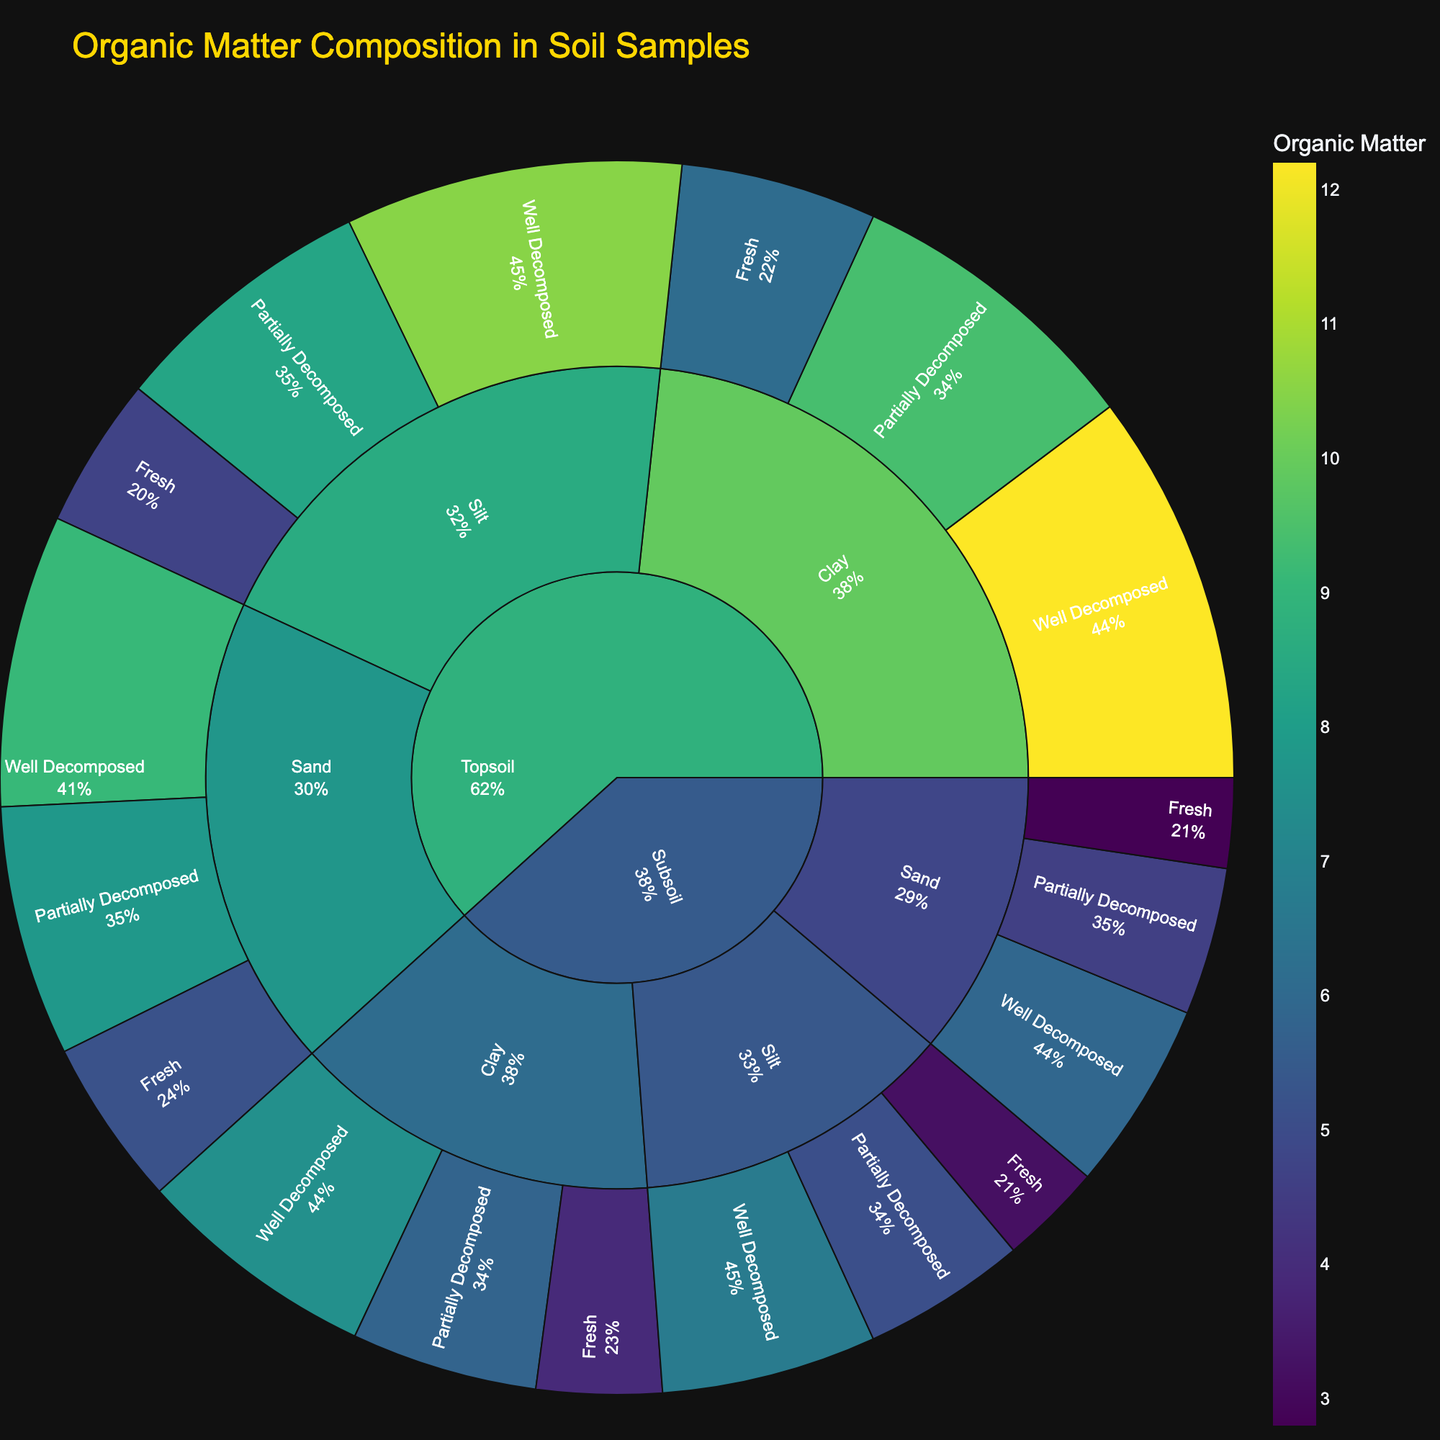What is the title of the sunburst plot? The title is displayed at the top of the plot, usually in a larger font compared to other text elements. It summarizes what the plot is about.
Answer: Organic Matter Composition in Soil Samples Which decomposition stage has the highest proportion of organic matter in topsoil silt? To find this, observe the segments under 'Topsoil' > 'Silt' and compare proportions of 'Fresh', 'Partially Decomposed', and 'Well Decomposed' stages. The 'Well Decomposed' stage will have the largest segment.
Answer: Well Decomposed What is the total organic matter content for topsoil clay? Sum the values for topsoil clay across all decomposition stages. Add the values for 'Fresh' (6.1), 'Partially Decomposed' (9.4), and 'Well Decomposed' (12.2).
Answer: 27.7 Is the organic matter content higher in subsoil silt or subsoil sand for the well-decomposed stage? Compare the 'OrganicMatter' values for 'Subsoil' > 'Silt' > 'Well Decomposed' (6.7) and 'Subsoil' > 'Sand' > 'Well Decomposed' (5.9).
Answer: Subsoil Silt Which particle size in topsoil has the smallest proportion of organic matter in the fresh decomposition stage? Under 'Topsoil', compare the 'Fresh' segments for 'Sand' (5.2), 'Silt' (4.7), and 'Clay' (6.1). The smallest value is for 'Silt'.
Answer: Silt What is the percentage of organic matter in partially decomposed subsoil sand relative to total subsoil sand? First, find the total for 'Subsoil' > 'Sand' by adding values for all decomposition stages: 2.8 + 4.6 + 5.9 = 13.3. Then, calculate (4.6 / 13.3) * 100.
Answer: Approximately 34.6% Which has a higher organic matter content: subsoil clay in the fresh stage or subsoil silt in the partially decomposed stage? Compare the values 'Subsoil' > 'Clay' > 'Fresh' (3.9) with 'Subsoil' > 'Silt' > 'Partially Decomposed' (5.1).
Answer: Subsoil Silt in Partially Decomposed Stage What is the relative proportion of organic matter in well-decomposed topsoil clay compared to well-decomposed topsoil sand? Compare 'Topsoil' > 'Clay' > 'Well Decomposed' (12.2) with 'Topsoil' > 'Sand' > 'Well Decomposed' (9.1).
Answer: Higher How does the proportion of fresh decomposition stage in topsoil sand compare to subsoil sand? Compare the 'Fresh' segments under 'Topsoil' > 'Sand' (5.2) and 'Subsoil' > 'Sand' (2.8).
Answer: Topsoil Sand has a higher proportion What is the difference in organic matter content between well-decomposed topsoil silt and well-decomposed subsoil silt? Subtract the value for 'Subsoil' > 'Silt' > 'Well Decomposed' (6.7) from 'Topsoil' > 'Silt' > 'Well Decomposed' (10.5).
Answer: 3.8 